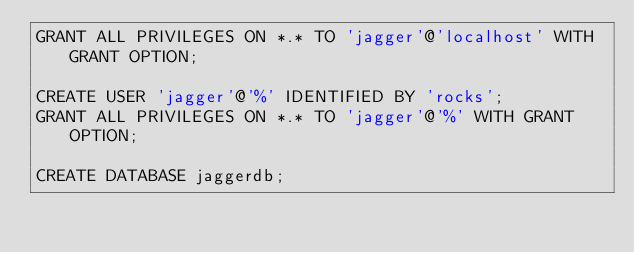Convert code to text. <code><loc_0><loc_0><loc_500><loc_500><_SQL_>GRANT ALL PRIVILEGES ON *.* TO 'jagger'@'localhost' WITH GRANT OPTION;

CREATE USER 'jagger'@'%' IDENTIFIED BY 'rocks';
GRANT ALL PRIVILEGES ON *.* TO 'jagger'@'%' WITH GRANT OPTION;

CREATE DATABASE jaggerdb;
</code> 